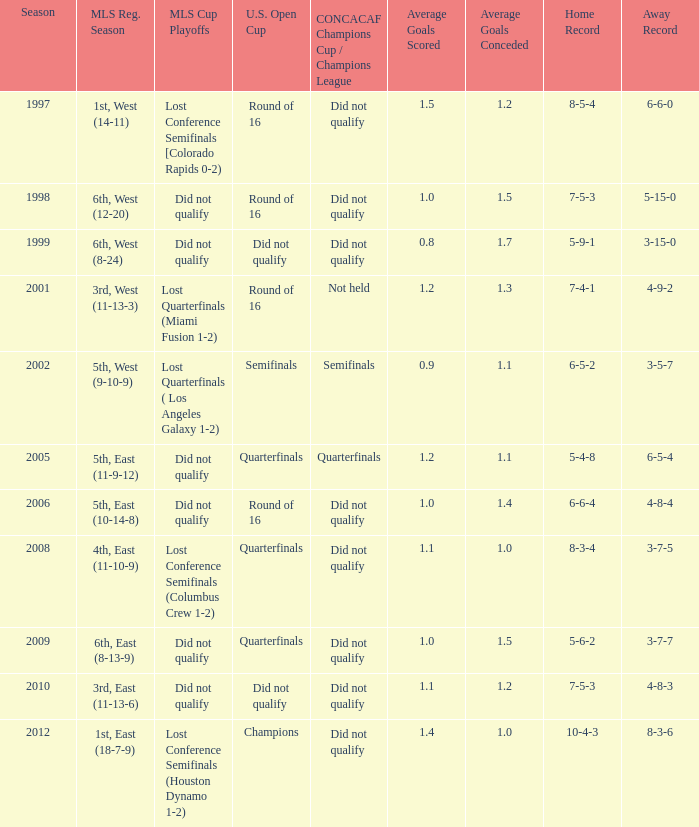How did the team place when they did not qualify for the Concaf Champions Cup but made it to Round of 16 in the U.S. Open Cup? Lost Conference Semifinals [Colorado Rapids 0-2), Did not qualify, Did not qualify. 